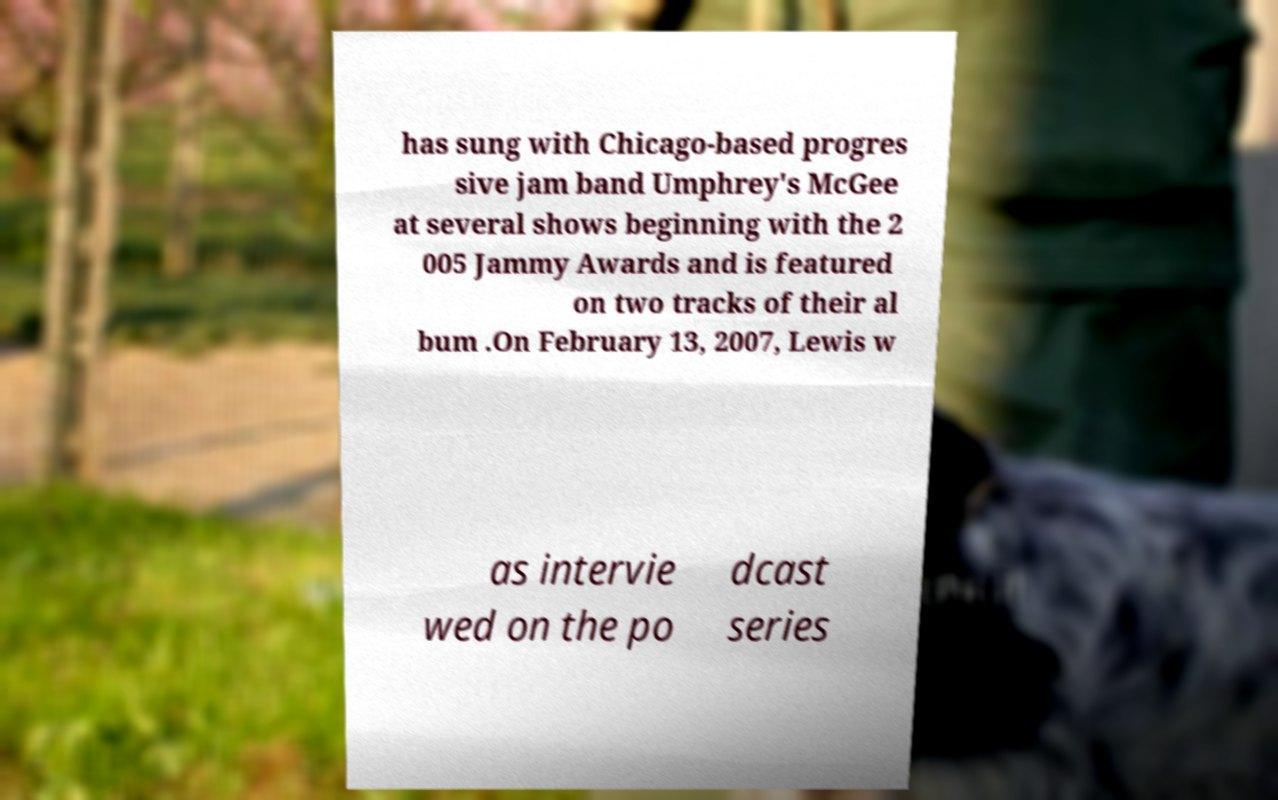Please read and relay the text visible in this image. What does it say? has sung with Chicago-based progres sive jam band Umphrey's McGee at several shows beginning with the 2 005 Jammy Awards and is featured on two tracks of their al bum .On February 13, 2007, Lewis w as intervie wed on the po dcast series 